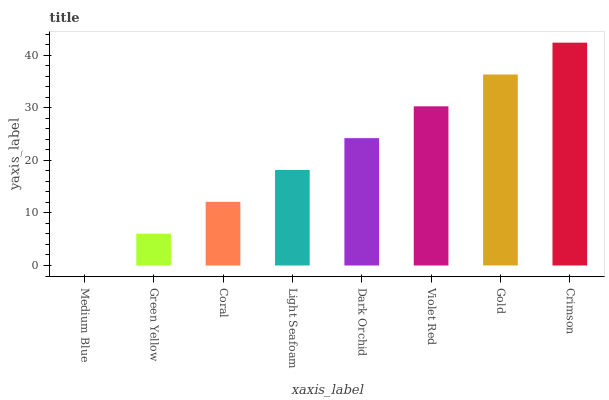Is Medium Blue the minimum?
Answer yes or no. Yes. Is Crimson the maximum?
Answer yes or no. Yes. Is Green Yellow the minimum?
Answer yes or no. No. Is Green Yellow the maximum?
Answer yes or no. No. Is Green Yellow greater than Medium Blue?
Answer yes or no. Yes. Is Medium Blue less than Green Yellow?
Answer yes or no. Yes. Is Medium Blue greater than Green Yellow?
Answer yes or no. No. Is Green Yellow less than Medium Blue?
Answer yes or no. No. Is Dark Orchid the high median?
Answer yes or no. Yes. Is Light Seafoam the low median?
Answer yes or no. Yes. Is Crimson the high median?
Answer yes or no. No. Is Coral the low median?
Answer yes or no. No. 